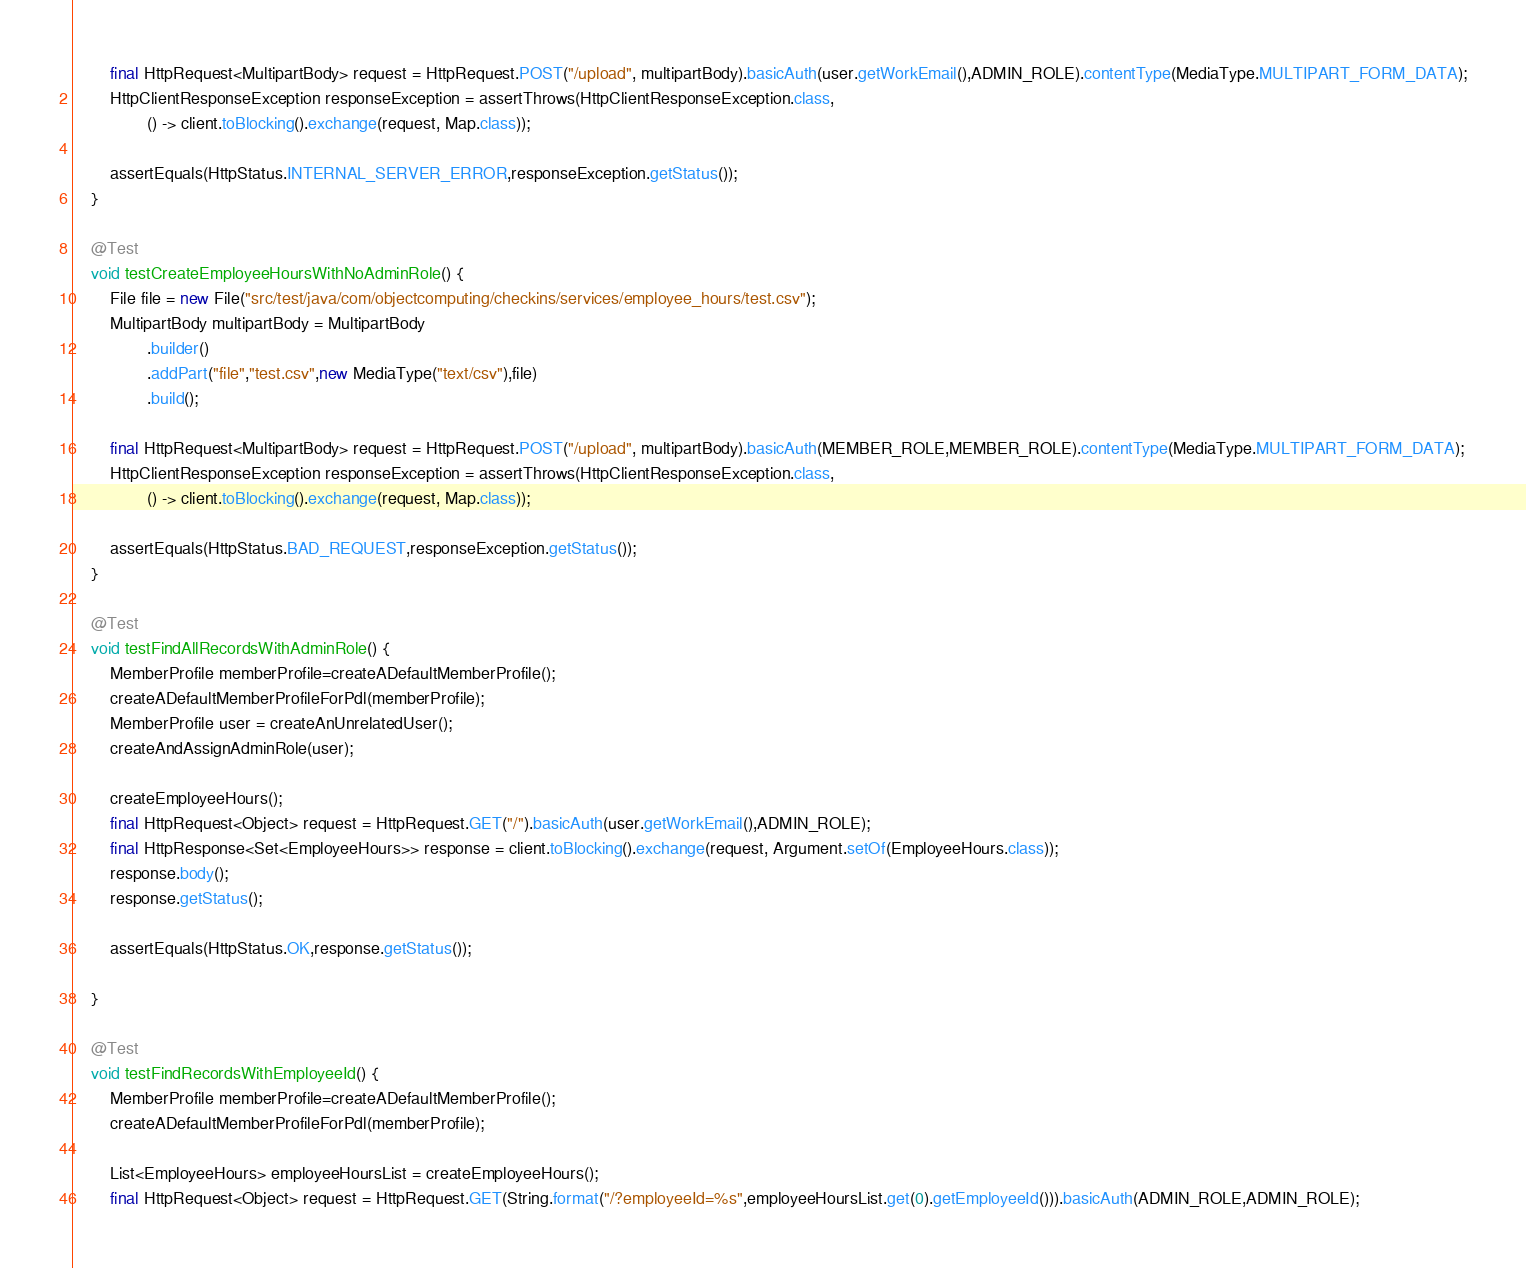Convert code to text. <code><loc_0><loc_0><loc_500><loc_500><_Java_>
        final HttpRequest<MultipartBody> request = HttpRequest.POST("/upload", multipartBody).basicAuth(user.getWorkEmail(),ADMIN_ROLE).contentType(MediaType.MULTIPART_FORM_DATA);
        HttpClientResponseException responseException = assertThrows(HttpClientResponseException.class,
                () -> client.toBlocking().exchange(request, Map.class));

        assertEquals(HttpStatus.INTERNAL_SERVER_ERROR,responseException.getStatus());
    }

    @Test
    void testCreateEmployeeHoursWithNoAdminRole() {
        File file = new File("src/test/java/com/objectcomputing/checkins/services/employee_hours/test.csv");
        MultipartBody multipartBody = MultipartBody
                .builder()
                .addPart("file","test.csv",new MediaType("text/csv"),file)
                .build();

        final HttpRequest<MultipartBody> request = HttpRequest.POST("/upload", multipartBody).basicAuth(MEMBER_ROLE,MEMBER_ROLE).contentType(MediaType.MULTIPART_FORM_DATA);
        HttpClientResponseException responseException = assertThrows(HttpClientResponseException.class,
                () -> client.toBlocking().exchange(request, Map.class));

        assertEquals(HttpStatus.BAD_REQUEST,responseException.getStatus());
    }

    @Test
    void testFindAllRecordsWithAdminRole() {
        MemberProfile memberProfile=createADefaultMemberProfile();
        createADefaultMemberProfileForPdl(memberProfile);
        MemberProfile user = createAnUnrelatedUser();
        createAndAssignAdminRole(user);

        createEmployeeHours();
        final HttpRequest<Object> request = HttpRequest.GET("/").basicAuth(user.getWorkEmail(),ADMIN_ROLE);
        final HttpResponse<Set<EmployeeHours>> response = client.toBlocking().exchange(request, Argument.setOf(EmployeeHours.class));
        response.body();
        response.getStatus();

        assertEquals(HttpStatus.OK,response.getStatus());

    }

    @Test
    void testFindRecordsWithEmployeeId() {
        MemberProfile memberProfile=createADefaultMemberProfile();
        createADefaultMemberProfileForPdl(memberProfile);

        List<EmployeeHours> employeeHoursList = createEmployeeHours();
        final HttpRequest<Object> request = HttpRequest.GET(String.format("/?employeeId=%s",employeeHoursList.get(0).getEmployeeId())).basicAuth(ADMIN_ROLE,ADMIN_ROLE);</code> 